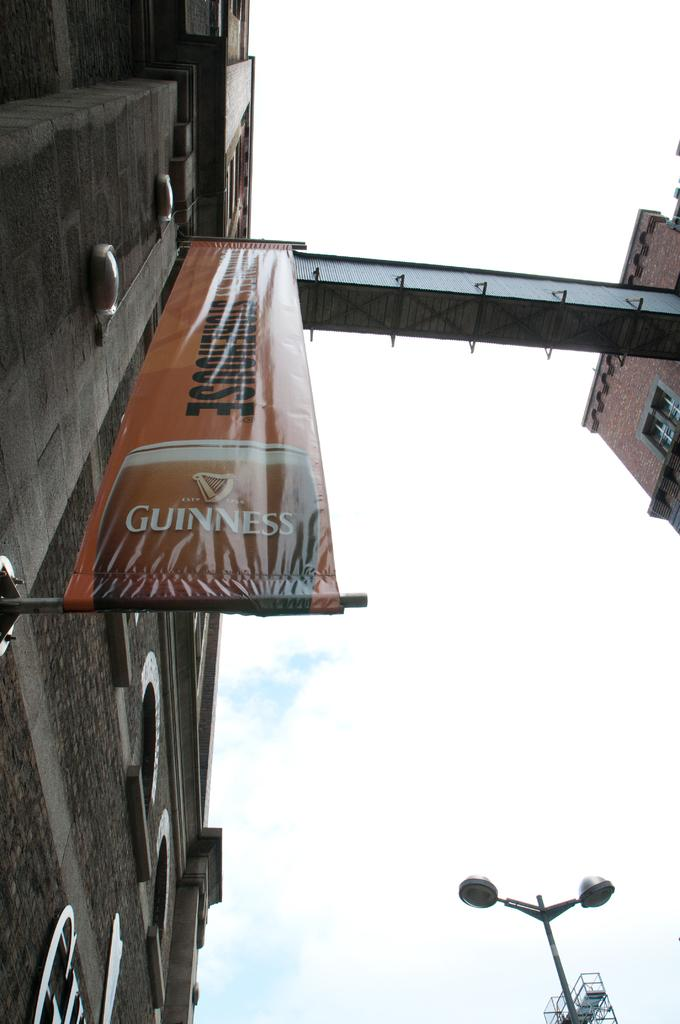What type of structure is present in the image? There is a building in the image. What feature can be seen on the building? The building has windows. What additional object is present in the image? There is a banner in the image. Can you describe another object in the image? There is a pole in the image. What can be seen illuminating the scene? There are lights in the image. What is visible in the background of the image? The sky is visible in the background of the image, and there are clouds in the sky. Where is the marble located in the image? There is no marble present in the image. What type of food is being served in the lunchroom in the image? There is no lunchroom present in the image. 